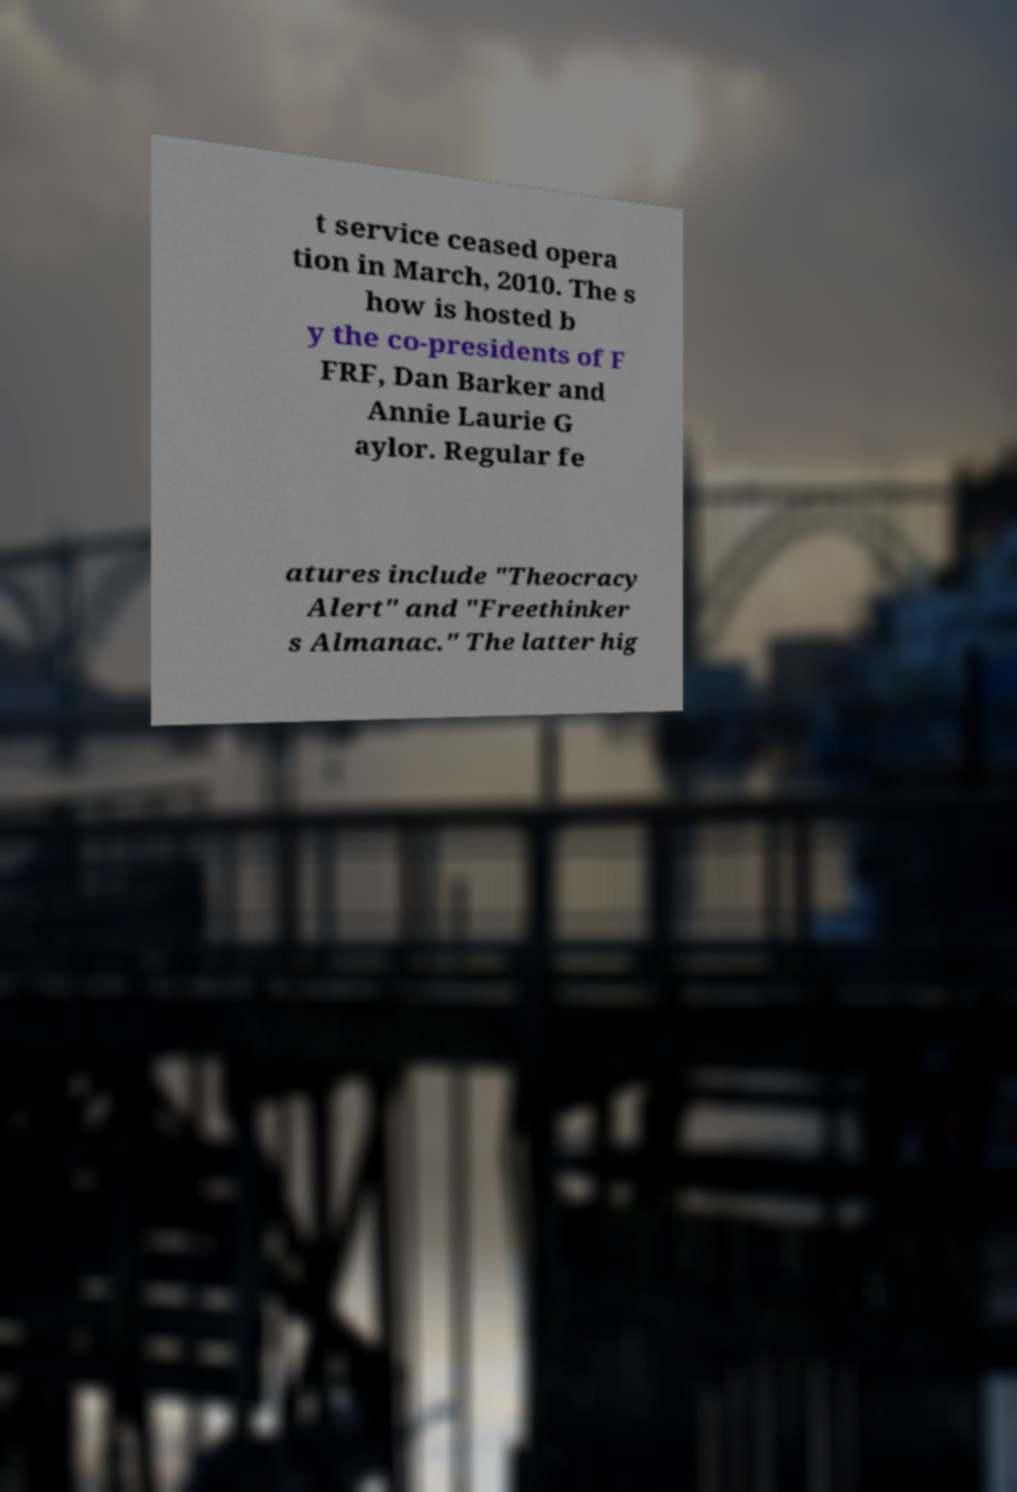Could you extract and type out the text from this image? t service ceased opera tion in March, 2010. The s how is hosted b y the co-presidents of F FRF, Dan Barker and Annie Laurie G aylor. Regular fe atures include "Theocracy Alert" and "Freethinker s Almanac." The latter hig 